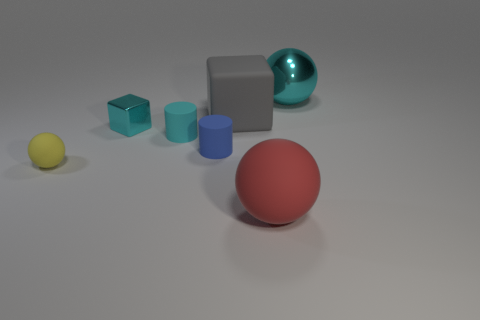Add 2 cylinders. How many objects exist? 9 Subtract all cubes. How many objects are left? 5 Add 5 tiny cyan matte things. How many tiny cyan matte things are left? 6 Add 3 big red metal blocks. How many big red metal blocks exist? 3 Subtract 0 blue spheres. How many objects are left? 7 Subtract all matte spheres. Subtract all big metal objects. How many objects are left? 4 